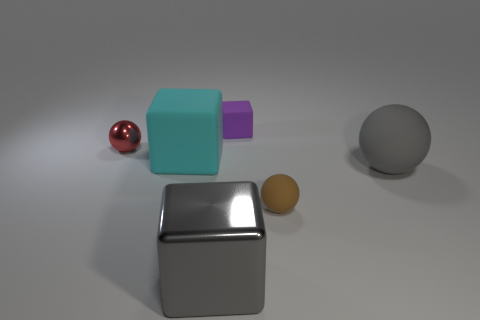Add 2 tiny red objects. How many objects exist? 8 Add 6 big shiny objects. How many big shiny objects are left? 7 Add 2 big matte objects. How many big matte objects exist? 4 Subtract 0 purple balls. How many objects are left? 6 Subtract all tiny red shiny blocks. Subtract all brown matte objects. How many objects are left? 5 